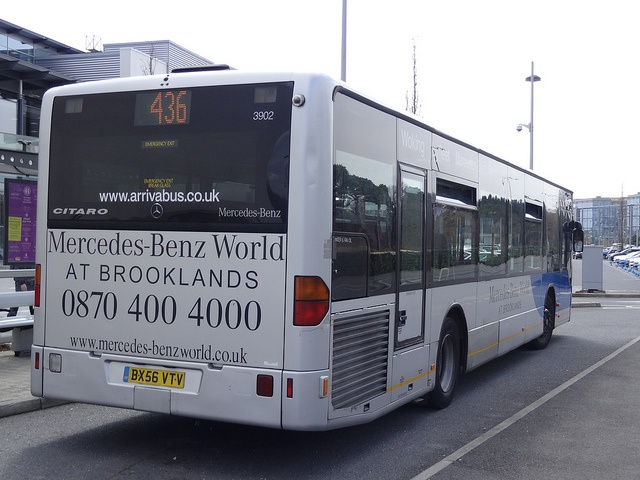Describe the objects in this image and their specific colors. I can see bus in white, darkgray, black, and gray tones, car in white, gray, and darkgray tones, car in white, darkgray, gray, and lavender tones, car in white, darkgray, gray, and navy tones, and car in white, gray, and darkgray tones in this image. 